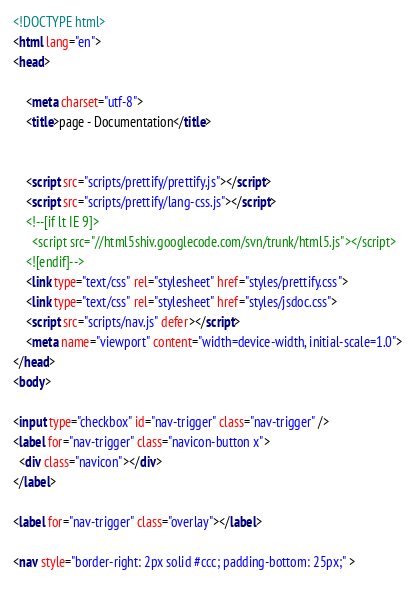Convert code to text. <code><loc_0><loc_0><loc_500><loc_500><_HTML_><!DOCTYPE html>
<html lang="en">
<head>
    
    <meta charset="utf-8">
    <title>page - Documentation</title>
    
    
    <script src="scripts/prettify/prettify.js"></script>
    <script src="scripts/prettify/lang-css.js"></script>
    <!--[if lt IE 9]>
      <script src="//html5shiv.googlecode.com/svn/trunk/html5.js"></script>
    <![endif]-->
    <link type="text/css" rel="stylesheet" href="styles/prettify.css">
    <link type="text/css" rel="stylesheet" href="styles/jsdoc.css">
    <script src="scripts/nav.js" defer></script>
    <meta name="viewport" content="width=device-width, initial-scale=1.0">
</head>
<body>

<input type="checkbox" id="nav-trigger" class="nav-trigger" />
<label for="nav-trigger" class="navicon-button x">
  <div class="navicon"></div>
</label>

<label for="nav-trigger" class="overlay"></label>

<nav style="border-right: 2px solid #ccc; padding-bottom: 25px;" >
    </code> 